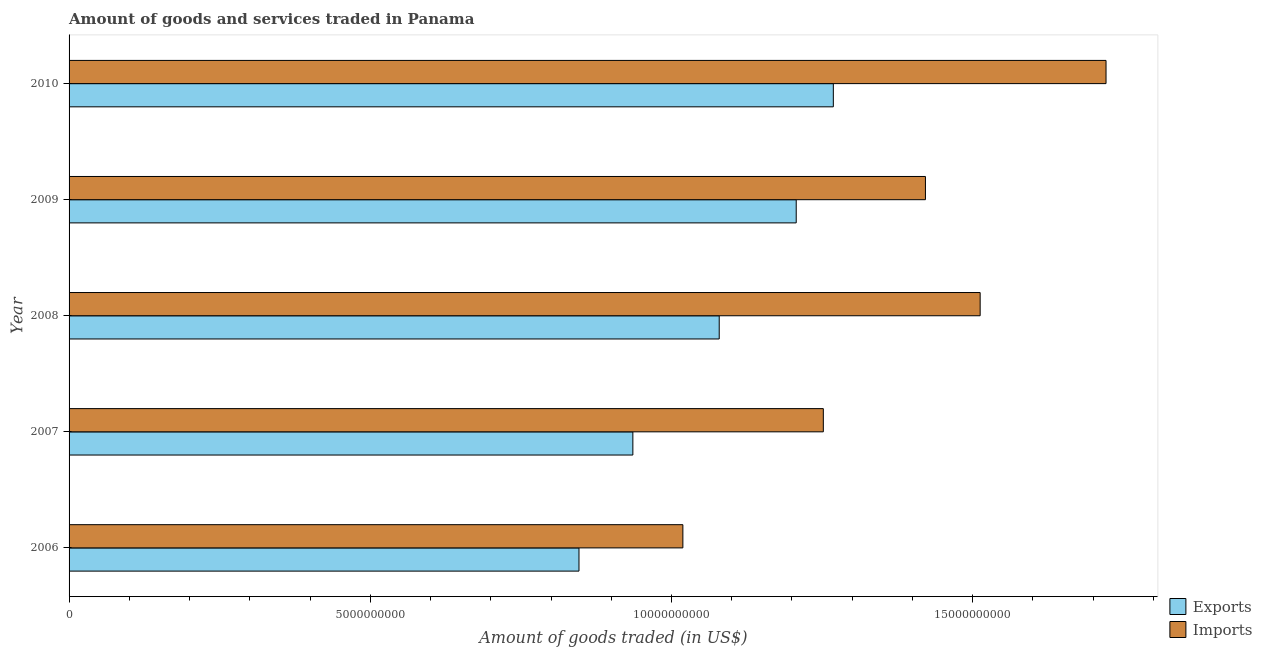How many different coloured bars are there?
Your answer should be compact. 2. How many groups of bars are there?
Offer a very short reply. 5. What is the label of the 5th group of bars from the top?
Your response must be concise. 2006. In how many cases, is the number of bars for a given year not equal to the number of legend labels?
Give a very brief answer. 0. What is the amount of goods imported in 2009?
Your response must be concise. 1.42e+1. Across all years, what is the maximum amount of goods exported?
Offer a very short reply. 1.27e+1. Across all years, what is the minimum amount of goods imported?
Your answer should be very brief. 1.02e+1. What is the total amount of goods exported in the graph?
Keep it short and to the point. 5.34e+1. What is the difference between the amount of goods imported in 2006 and that in 2008?
Ensure brevity in your answer.  -4.93e+09. What is the difference between the amount of goods exported in 2006 and the amount of goods imported in 2007?
Offer a terse response. -4.06e+09. What is the average amount of goods exported per year?
Offer a very short reply. 1.07e+1. In the year 2010, what is the difference between the amount of goods exported and amount of goods imported?
Offer a terse response. -4.53e+09. In how many years, is the amount of goods imported greater than 6000000000 US$?
Keep it short and to the point. 5. What is the ratio of the amount of goods exported in 2009 to that in 2010?
Provide a succinct answer. 0.95. Is the amount of goods imported in 2007 less than that in 2008?
Give a very brief answer. Yes. What is the difference between the highest and the second highest amount of goods imported?
Make the answer very short. 2.09e+09. What is the difference between the highest and the lowest amount of goods imported?
Your answer should be very brief. 7.02e+09. In how many years, is the amount of goods imported greater than the average amount of goods imported taken over all years?
Offer a very short reply. 3. Is the sum of the amount of goods imported in 2007 and 2010 greater than the maximum amount of goods exported across all years?
Make the answer very short. Yes. What does the 1st bar from the top in 2008 represents?
Ensure brevity in your answer.  Imports. What does the 1st bar from the bottom in 2006 represents?
Your answer should be very brief. Exports. How many bars are there?
Keep it short and to the point. 10. Are all the bars in the graph horizontal?
Keep it short and to the point. Yes. How many years are there in the graph?
Make the answer very short. 5. Are the values on the major ticks of X-axis written in scientific E-notation?
Make the answer very short. No. Does the graph contain grids?
Keep it short and to the point. No. How many legend labels are there?
Offer a very short reply. 2. What is the title of the graph?
Provide a succinct answer. Amount of goods and services traded in Panama. What is the label or title of the X-axis?
Your answer should be very brief. Amount of goods traded (in US$). What is the Amount of goods traded (in US$) of Exports in 2006?
Make the answer very short. 8.46e+09. What is the Amount of goods traded (in US$) of Imports in 2006?
Your response must be concise. 1.02e+1. What is the Amount of goods traded (in US$) in Exports in 2007?
Give a very brief answer. 9.36e+09. What is the Amount of goods traded (in US$) in Imports in 2007?
Your answer should be compact. 1.25e+1. What is the Amount of goods traded (in US$) in Exports in 2008?
Your answer should be compact. 1.08e+1. What is the Amount of goods traded (in US$) in Imports in 2008?
Ensure brevity in your answer.  1.51e+1. What is the Amount of goods traded (in US$) of Exports in 2009?
Offer a very short reply. 1.21e+1. What is the Amount of goods traded (in US$) in Imports in 2009?
Your answer should be compact. 1.42e+1. What is the Amount of goods traded (in US$) of Exports in 2010?
Ensure brevity in your answer.  1.27e+1. What is the Amount of goods traded (in US$) of Imports in 2010?
Your response must be concise. 1.72e+1. Across all years, what is the maximum Amount of goods traded (in US$) of Exports?
Your answer should be very brief. 1.27e+1. Across all years, what is the maximum Amount of goods traded (in US$) in Imports?
Your answer should be very brief. 1.72e+1. Across all years, what is the minimum Amount of goods traded (in US$) in Exports?
Give a very brief answer. 8.46e+09. Across all years, what is the minimum Amount of goods traded (in US$) in Imports?
Your answer should be compact. 1.02e+1. What is the total Amount of goods traded (in US$) in Exports in the graph?
Offer a terse response. 5.34e+1. What is the total Amount of goods traded (in US$) in Imports in the graph?
Ensure brevity in your answer.  6.93e+1. What is the difference between the Amount of goods traded (in US$) of Exports in 2006 and that in 2007?
Your answer should be very brief. -8.94e+08. What is the difference between the Amount of goods traded (in US$) of Imports in 2006 and that in 2007?
Your response must be concise. -2.33e+09. What is the difference between the Amount of goods traded (in US$) in Exports in 2006 and that in 2008?
Keep it short and to the point. -2.33e+09. What is the difference between the Amount of goods traded (in US$) of Imports in 2006 and that in 2008?
Ensure brevity in your answer.  -4.93e+09. What is the difference between the Amount of goods traded (in US$) in Exports in 2006 and that in 2009?
Keep it short and to the point. -3.61e+09. What is the difference between the Amount of goods traded (in US$) in Imports in 2006 and that in 2009?
Offer a very short reply. -4.03e+09. What is the difference between the Amount of goods traded (in US$) in Exports in 2006 and that in 2010?
Give a very brief answer. -4.22e+09. What is the difference between the Amount of goods traded (in US$) of Imports in 2006 and that in 2010?
Give a very brief answer. -7.02e+09. What is the difference between the Amount of goods traded (in US$) in Exports in 2007 and that in 2008?
Ensure brevity in your answer.  -1.43e+09. What is the difference between the Amount of goods traded (in US$) in Imports in 2007 and that in 2008?
Your answer should be very brief. -2.60e+09. What is the difference between the Amount of goods traded (in US$) of Exports in 2007 and that in 2009?
Offer a very short reply. -2.71e+09. What is the difference between the Amount of goods traded (in US$) in Imports in 2007 and that in 2009?
Offer a very short reply. -1.70e+09. What is the difference between the Amount of goods traded (in US$) of Exports in 2007 and that in 2010?
Your answer should be compact. -3.33e+09. What is the difference between the Amount of goods traded (in US$) of Imports in 2007 and that in 2010?
Provide a succinct answer. -4.69e+09. What is the difference between the Amount of goods traded (in US$) in Exports in 2008 and that in 2009?
Offer a very short reply. -1.28e+09. What is the difference between the Amount of goods traded (in US$) of Imports in 2008 and that in 2009?
Offer a very short reply. 9.08e+08. What is the difference between the Amount of goods traded (in US$) of Exports in 2008 and that in 2010?
Your answer should be compact. -1.89e+09. What is the difference between the Amount of goods traded (in US$) of Imports in 2008 and that in 2010?
Offer a terse response. -2.09e+09. What is the difference between the Amount of goods traded (in US$) in Exports in 2009 and that in 2010?
Offer a terse response. -6.16e+08. What is the difference between the Amount of goods traded (in US$) of Imports in 2009 and that in 2010?
Keep it short and to the point. -3.00e+09. What is the difference between the Amount of goods traded (in US$) in Exports in 2006 and the Amount of goods traded (in US$) in Imports in 2007?
Provide a short and direct response. -4.06e+09. What is the difference between the Amount of goods traded (in US$) in Exports in 2006 and the Amount of goods traded (in US$) in Imports in 2008?
Offer a terse response. -6.66e+09. What is the difference between the Amount of goods traded (in US$) of Exports in 2006 and the Amount of goods traded (in US$) of Imports in 2009?
Offer a very short reply. -5.75e+09. What is the difference between the Amount of goods traded (in US$) of Exports in 2006 and the Amount of goods traded (in US$) of Imports in 2010?
Keep it short and to the point. -8.75e+09. What is the difference between the Amount of goods traded (in US$) of Exports in 2007 and the Amount of goods traded (in US$) of Imports in 2008?
Make the answer very short. -5.77e+09. What is the difference between the Amount of goods traded (in US$) of Exports in 2007 and the Amount of goods traded (in US$) of Imports in 2009?
Offer a very short reply. -4.86e+09. What is the difference between the Amount of goods traded (in US$) in Exports in 2007 and the Amount of goods traded (in US$) in Imports in 2010?
Give a very brief answer. -7.85e+09. What is the difference between the Amount of goods traded (in US$) of Exports in 2008 and the Amount of goods traded (in US$) of Imports in 2009?
Keep it short and to the point. -3.42e+09. What is the difference between the Amount of goods traded (in US$) in Exports in 2008 and the Amount of goods traded (in US$) in Imports in 2010?
Offer a very short reply. -6.42e+09. What is the difference between the Amount of goods traded (in US$) of Exports in 2009 and the Amount of goods traded (in US$) of Imports in 2010?
Your response must be concise. -5.14e+09. What is the average Amount of goods traded (in US$) in Exports per year?
Give a very brief answer. 1.07e+1. What is the average Amount of goods traded (in US$) in Imports per year?
Offer a terse response. 1.39e+1. In the year 2006, what is the difference between the Amount of goods traded (in US$) of Exports and Amount of goods traded (in US$) of Imports?
Your answer should be very brief. -1.72e+09. In the year 2007, what is the difference between the Amount of goods traded (in US$) of Exports and Amount of goods traded (in US$) of Imports?
Make the answer very short. -3.16e+09. In the year 2008, what is the difference between the Amount of goods traded (in US$) in Exports and Amount of goods traded (in US$) in Imports?
Your response must be concise. -4.33e+09. In the year 2009, what is the difference between the Amount of goods traded (in US$) in Exports and Amount of goods traded (in US$) in Imports?
Make the answer very short. -2.15e+09. In the year 2010, what is the difference between the Amount of goods traded (in US$) in Exports and Amount of goods traded (in US$) in Imports?
Offer a terse response. -4.53e+09. What is the ratio of the Amount of goods traded (in US$) of Exports in 2006 to that in 2007?
Provide a short and direct response. 0.9. What is the ratio of the Amount of goods traded (in US$) in Imports in 2006 to that in 2007?
Provide a succinct answer. 0.81. What is the ratio of the Amount of goods traded (in US$) in Exports in 2006 to that in 2008?
Provide a succinct answer. 0.78. What is the ratio of the Amount of goods traded (in US$) of Imports in 2006 to that in 2008?
Your response must be concise. 0.67. What is the ratio of the Amount of goods traded (in US$) in Exports in 2006 to that in 2009?
Keep it short and to the point. 0.7. What is the ratio of the Amount of goods traded (in US$) of Imports in 2006 to that in 2009?
Keep it short and to the point. 0.72. What is the ratio of the Amount of goods traded (in US$) in Exports in 2006 to that in 2010?
Your response must be concise. 0.67. What is the ratio of the Amount of goods traded (in US$) of Imports in 2006 to that in 2010?
Give a very brief answer. 0.59. What is the ratio of the Amount of goods traded (in US$) in Exports in 2007 to that in 2008?
Your response must be concise. 0.87. What is the ratio of the Amount of goods traded (in US$) in Imports in 2007 to that in 2008?
Provide a succinct answer. 0.83. What is the ratio of the Amount of goods traded (in US$) of Exports in 2007 to that in 2009?
Keep it short and to the point. 0.78. What is the ratio of the Amount of goods traded (in US$) in Imports in 2007 to that in 2009?
Provide a short and direct response. 0.88. What is the ratio of the Amount of goods traded (in US$) in Exports in 2007 to that in 2010?
Offer a terse response. 0.74. What is the ratio of the Amount of goods traded (in US$) in Imports in 2007 to that in 2010?
Your answer should be compact. 0.73. What is the ratio of the Amount of goods traded (in US$) in Exports in 2008 to that in 2009?
Provide a short and direct response. 0.89. What is the ratio of the Amount of goods traded (in US$) of Imports in 2008 to that in 2009?
Provide a succinct answer. 1.06. What is the ratio of the Amount of goods traded (in US$) of Exports in 2008 to that in 2010?
Provide a short and direct response. 0.85. What is the ratio of the Amount of goods traded (in US$) of Imports in 2008 to that in 2010?
Your answer should be very brief. 0.88. What is the ratio of the Amount of goods traded (in US$) of Exports in 2009 to that in 2010?
Provide a succinct answer. 0.95. What is the ratio of the Amount of goods traded (in US$) in Imports in 2009 to that in 2010?
Your response must be concise. 0.83. What is the difference between the highest and the second highest Amount of goods traded (in US$) of Exports?
Offer a terse response. 6.16e+08. What is the difference between the highest and the second highest Amount of goods traded (in US$) of Imports?
Make the answer very short. 2.09e+09. What is the difference between the highest and the lowest Amount of goods traded (in US$) of Exports?
Ensure brevity in your answer.  4.22e+09. What is the difference between the highest and the lowest Amount of goods traded (in US$) of Imports?
Your answer should be compact. 7.02e+09. 